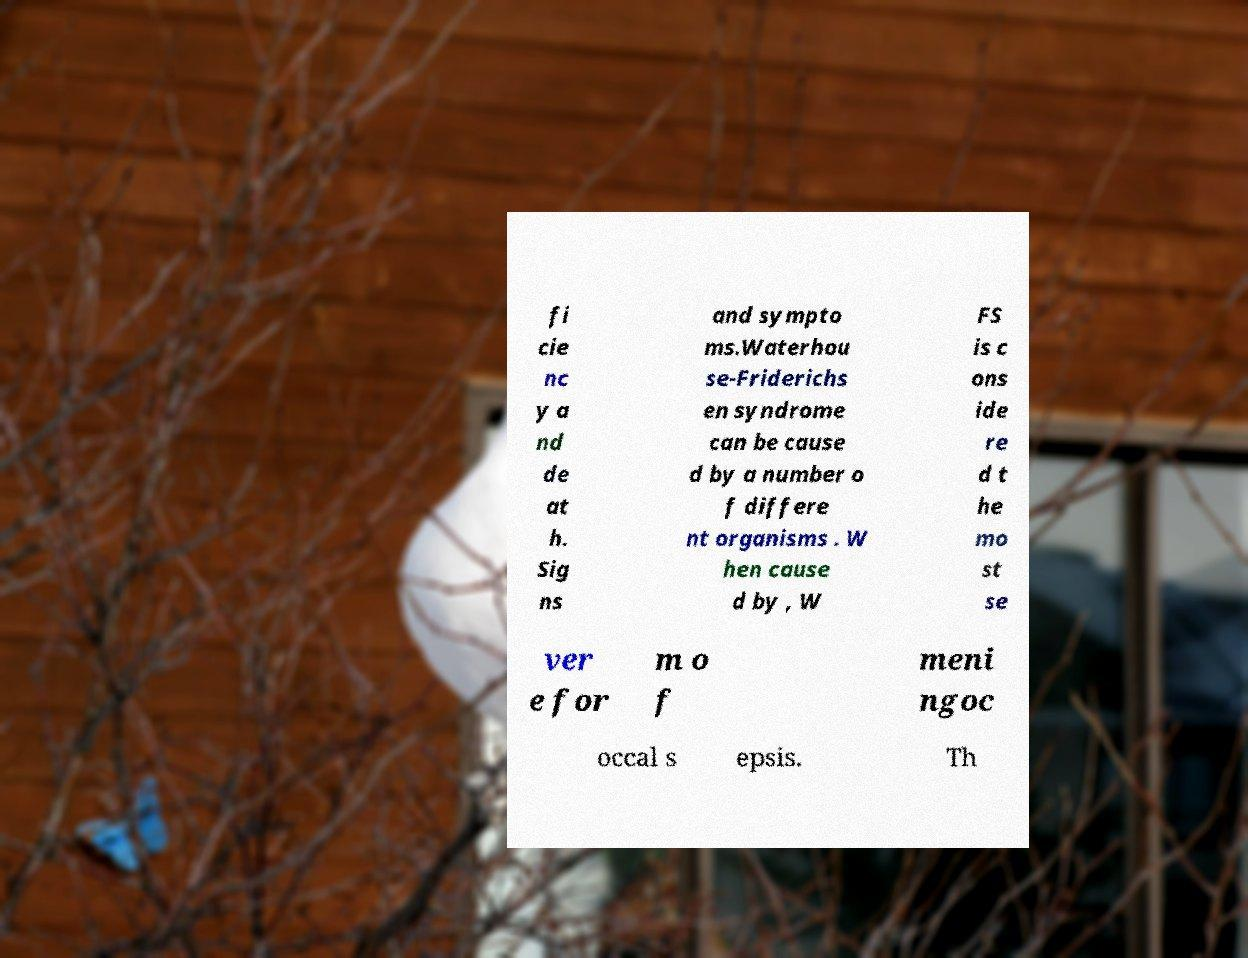Please identify and transcribe the text found in this image. fi cie nc y a nd de at h. Sig ns and sympto ms.Waterhou se-Friderichs en syndrome can be cause d by a number o f differe nt organisms . W hen cause d by , W FS is c ons ide re d t he mo st se ver e for m o f meni ngoc occal s epsis. Th 